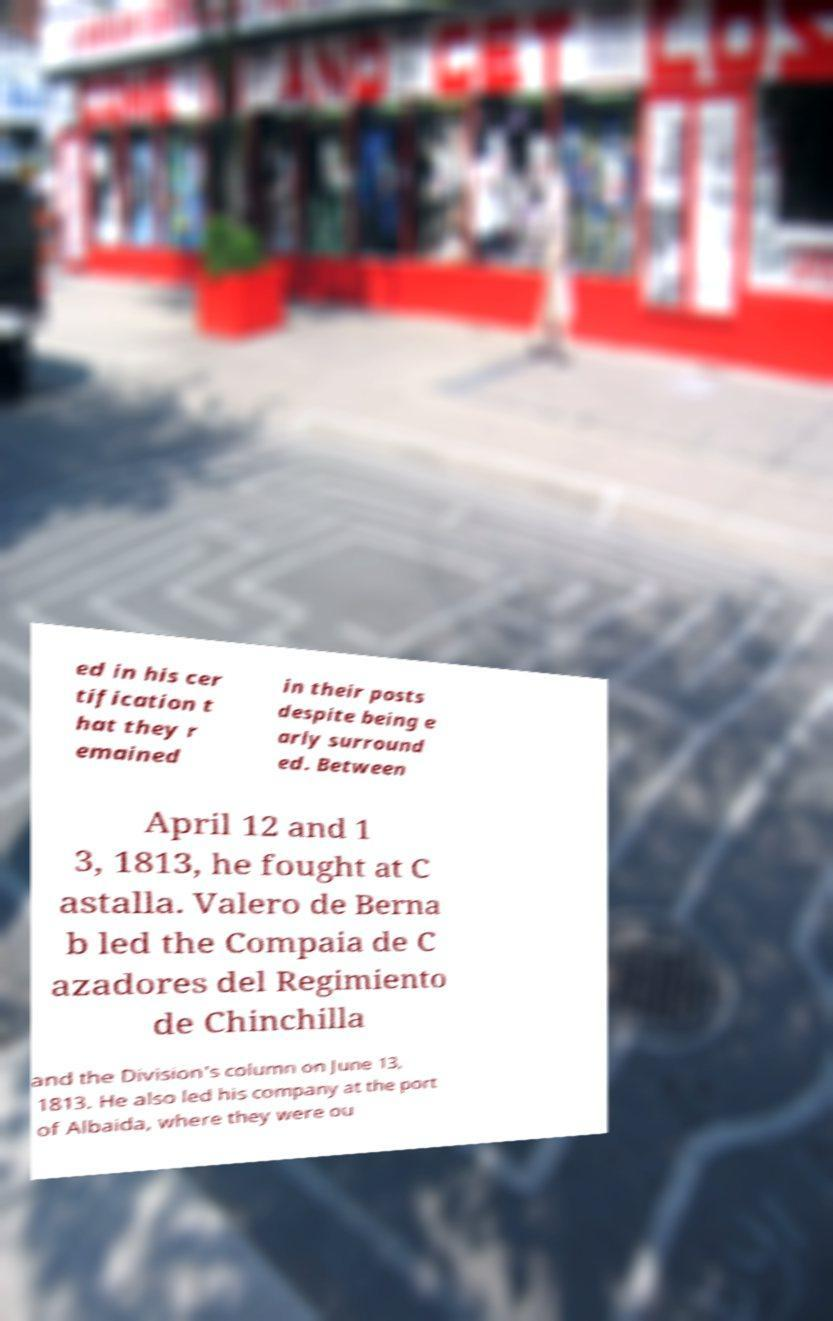Please identify and transcribe the text found in this image. ed in his cer tification t hat they r emained in their posts despite being e arly surround ed. Between April 12 and 1 3, 1813, he fought at C astalla. Valero de Berna b led the Compaia de C azadores del Regimiento de Chinchilla and the Division's column on June 13, 1813. He also led his company at the port of Albaida, where they were ou 